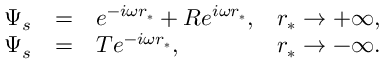Convert formula to latex. <formula><loc_0><loc_0><loc_500><loc_500>\begin{array} { c c l l } { \Psi _ { s } } & { = } & { e ^ { - i \omega r _ { * } } + R e ^ { i \omega r _ { * } } , } & { r _ { * } \rightarrow + \infty , } \\ { \Psi _ { s } } & { = } & { T e ^ { - i \omega r _ { * } } , } & { r _ { * } \rightarrow - \infty . } \end{array}</formula> 